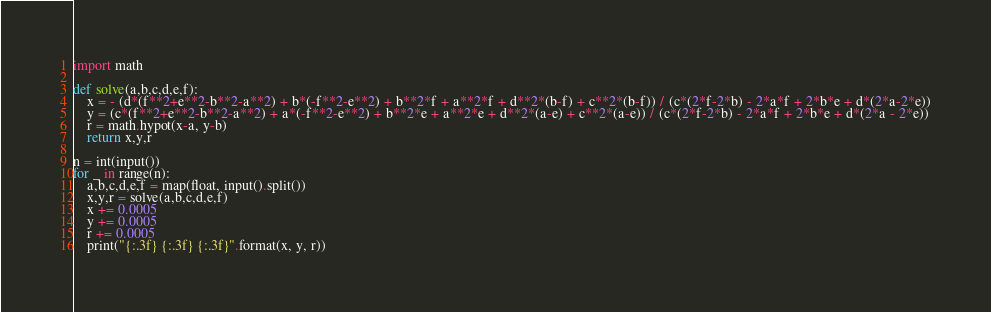<code> <loc_0><loc_0><loc_500><loc_500><_Python_>import math

def solve(a,b,c,d,e,f):
	x = - (d*(f**2+e**2-b**2-a**2) + b*(-f**2-e**2) + b**2*f + a**2*f + d**2*(b-f) + c**2*(b-f)) / (c*(2*f-2*b) - 2*a*f + 2*b*e + d*(2*a-2*e))
	y = (c*(f**2+e**2-b**2-a**2) + a*(-f**2-e**2) + b**2*e + a**2*e + d**2*(a-e) + c**2*(a-e)) / (c*(2*f-2*b) - 2*a*f + 2*b*e + d*(2*a - 2*e))
	r = math.hypot(x-a, y-b) 
	return x,y,r

n = int(input())
for _ in range(n):
	a,b,c,d,e,f = map(float, input().split())
	x,y,r = solve(a,b,c,d,e,f)
	x += 0.0005
	y += 0.0005
	r += 0.0005
	print("{:.3f} {:.3f} {:.3f}".format(x, y, r))</code> 